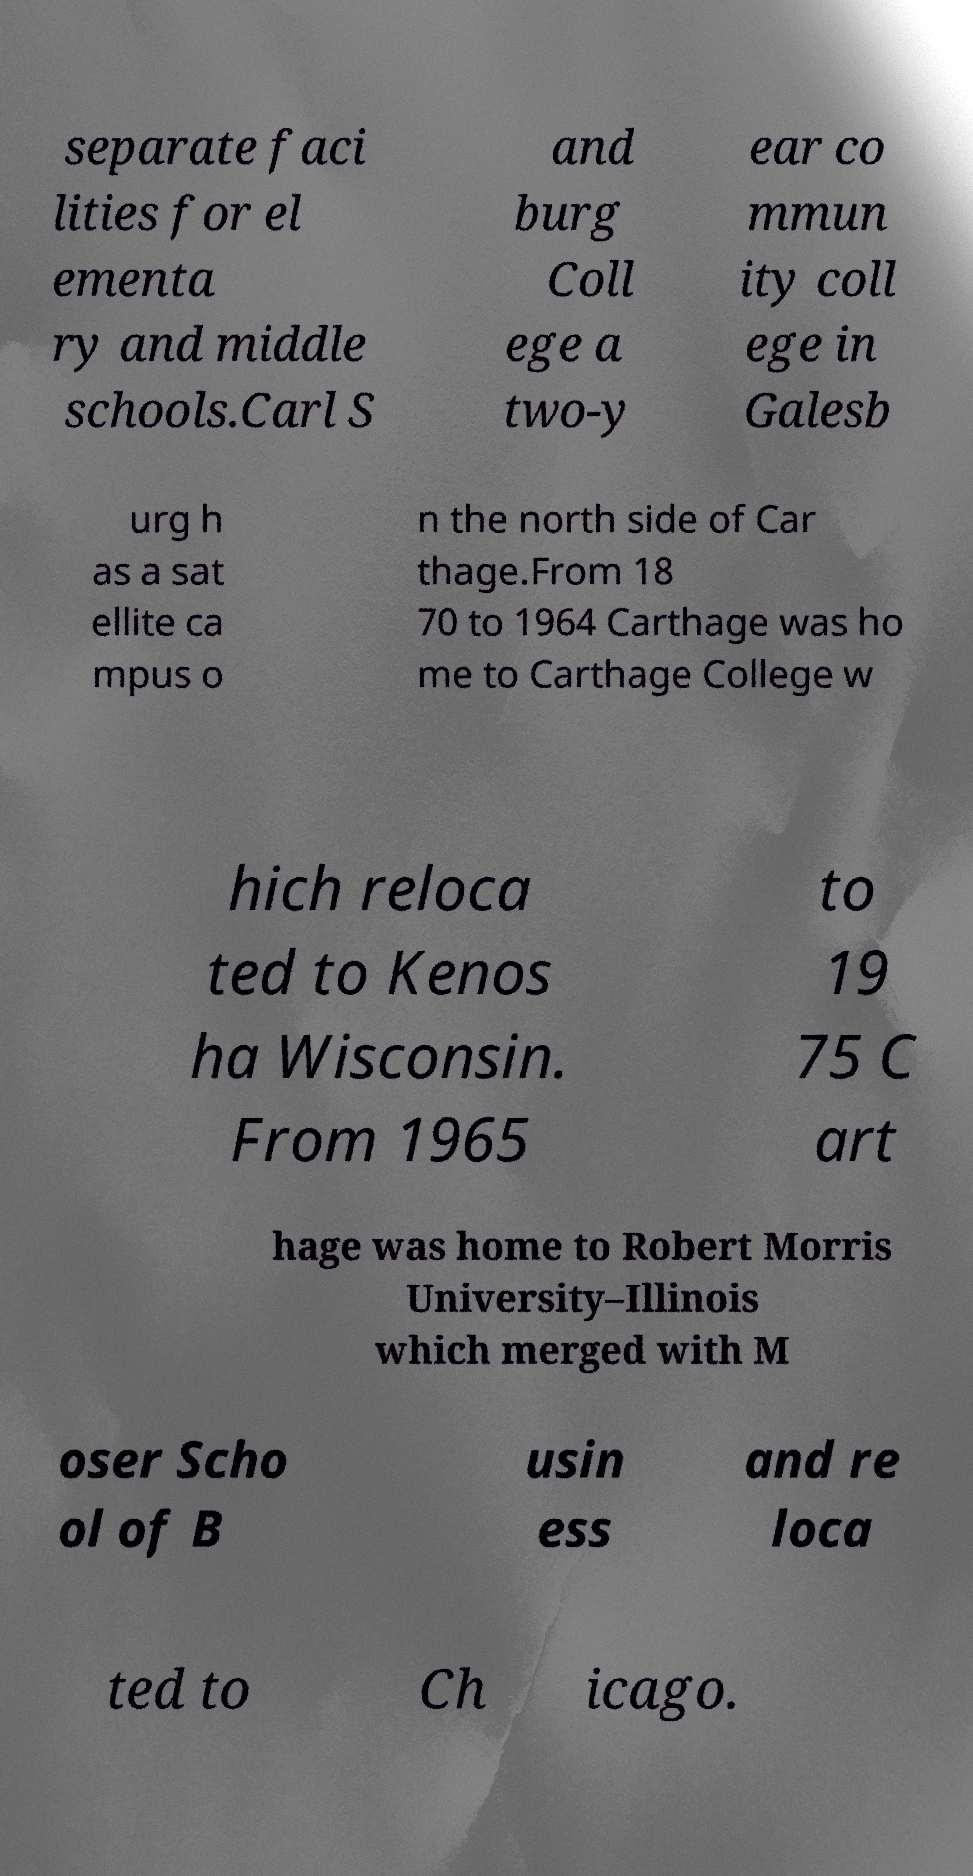I need the written content from this picture converted into text. Can you do that? separate faci lities for el ementa ry and middle schools.Carl S and burg Coll ege a two-y ear co mmun ity coll ege in Galesb urg h as a sat ellite ca mpus o n the north side of Car thage.From 18 70 to 1964 Carthage was ho me to Carthage College w hich reloca ted to Kenos ha Wisconsin. From 1965 to 19 75 C art hage was home to Robert Morris University–Illinois which merged with M oser Scho ol of B usin ess and re loca ted to Ch icago. 